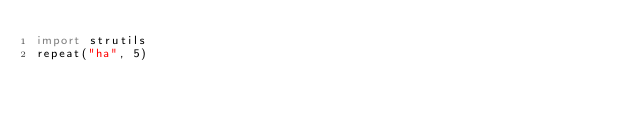<code> <loc_0><loc_0><loc_500><loc_500><_Nim_>import strutils
repeat("ha", 5)
</code> 